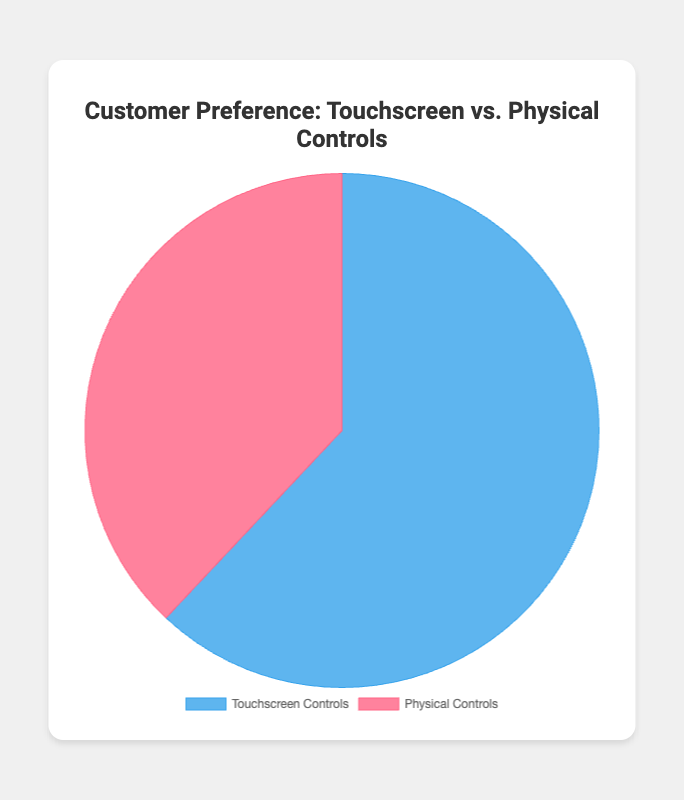What is the percentage preference for Touchscreen Controls? The figure shows that the percentage for Touchscreen Controls is indicated directly. This value can be read from the chart.
Answer: 62% How much more popular are Touchscreen Controls compared to Physical Controls? The percentage for Touchscreen Controls is 62% and for Physical Controls is 38%. Subtracting the percentage of Physical Controls from Touchscreen Controls gives the difference. 62% - 38% = 24%
Answer: 24% Which preference has a higher percentage in the chart? By comparing the percentages for Touchscreen Controls and Physical Controls, we see that Touchscreen Controls have 62% while Physical Controls have 38%. Touchscreen Controls have a higher percentage.
Answer: Touchscreen Controls What color represents Touchscreen Controls in the chart? Observing the pie chart, we can see that the segment corresponding to Touchscreen Controls is colored blue.
Answer: Blue If you combine the preferences of both control types, what is the total percentage? The pie chart represents two mutually exclusive preferences that sum up to the entire dataset. The total percentage is always 100%.
Answer: 100% What is the ratio of preference for Touchscreen Controls to Physical Controls? The percentage for Touchscreen Controls is 62%, and for Physical Controls, it is 38%. The ratio is calculated by dividing the percentages: 62 / 38 approximately equal to 1.63.
Answer: 1.63 What is the difference in percentages between Touchscreen Controls and Physical Controls? From the percentage values given in the chart, we subtract the smaller percentage (Physical Controls) from the larger (Touchscreen Controls): 62% - 38% = 24%
Answer: 24% What is the sum of the percentages for both control types? Adding the percentages for both preferences: 62% (Touchscreen Controls) + 38% (Physical Controls) = 100%
Answer: 100% 